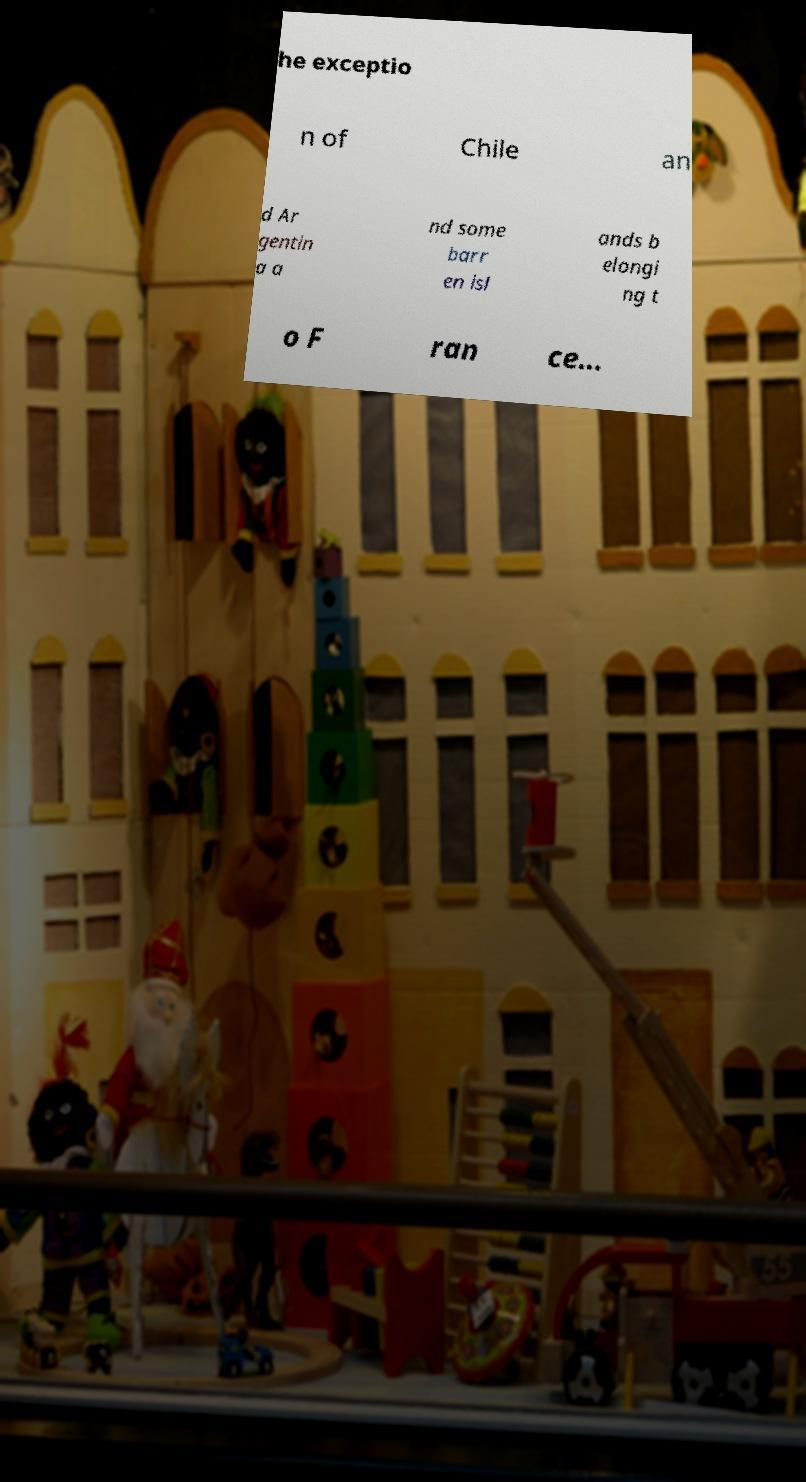Please identify and transcribe the text found in this image. he exceptio n of Chile an d Ar gentin a a nd some barr en isl ands b elongi ng t o F ran ce... 